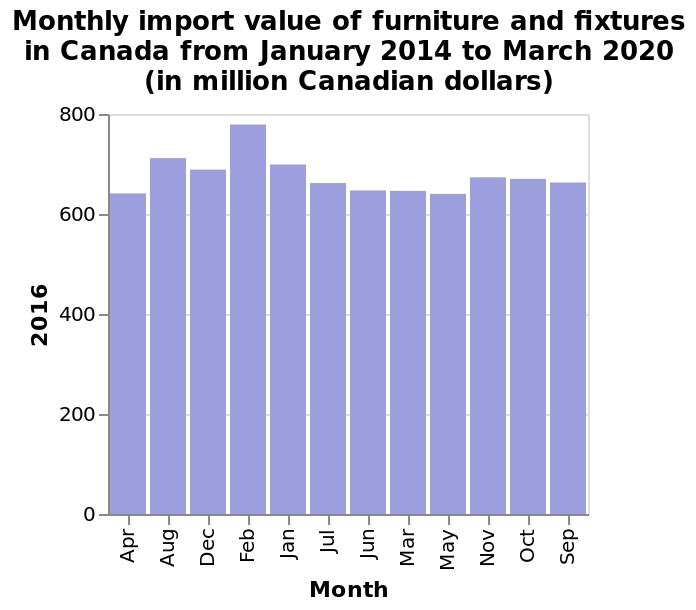<image>
please enumerates aspects of the construction of the chart This bar plot is titled Monthly import value of furniture and fixtures in Canada from January 2014 to March 2020 (in million Canadian dollars). There is a categorical scale from Apr to Sep along the x-axis, marked Month. 2016 is defined along the y-axis. Offer a thorough analysis of the image. In Feb 2016 the import value was the highest at slightly less than 800 million Canadian dollars. The months of April, June and March all have the same import value. The month of May has the lowest import value just slightly following the months of April, June & March. Which month had the lowest import value? The month of May had the lowest import value, slightly following the months of April, June, and March. 